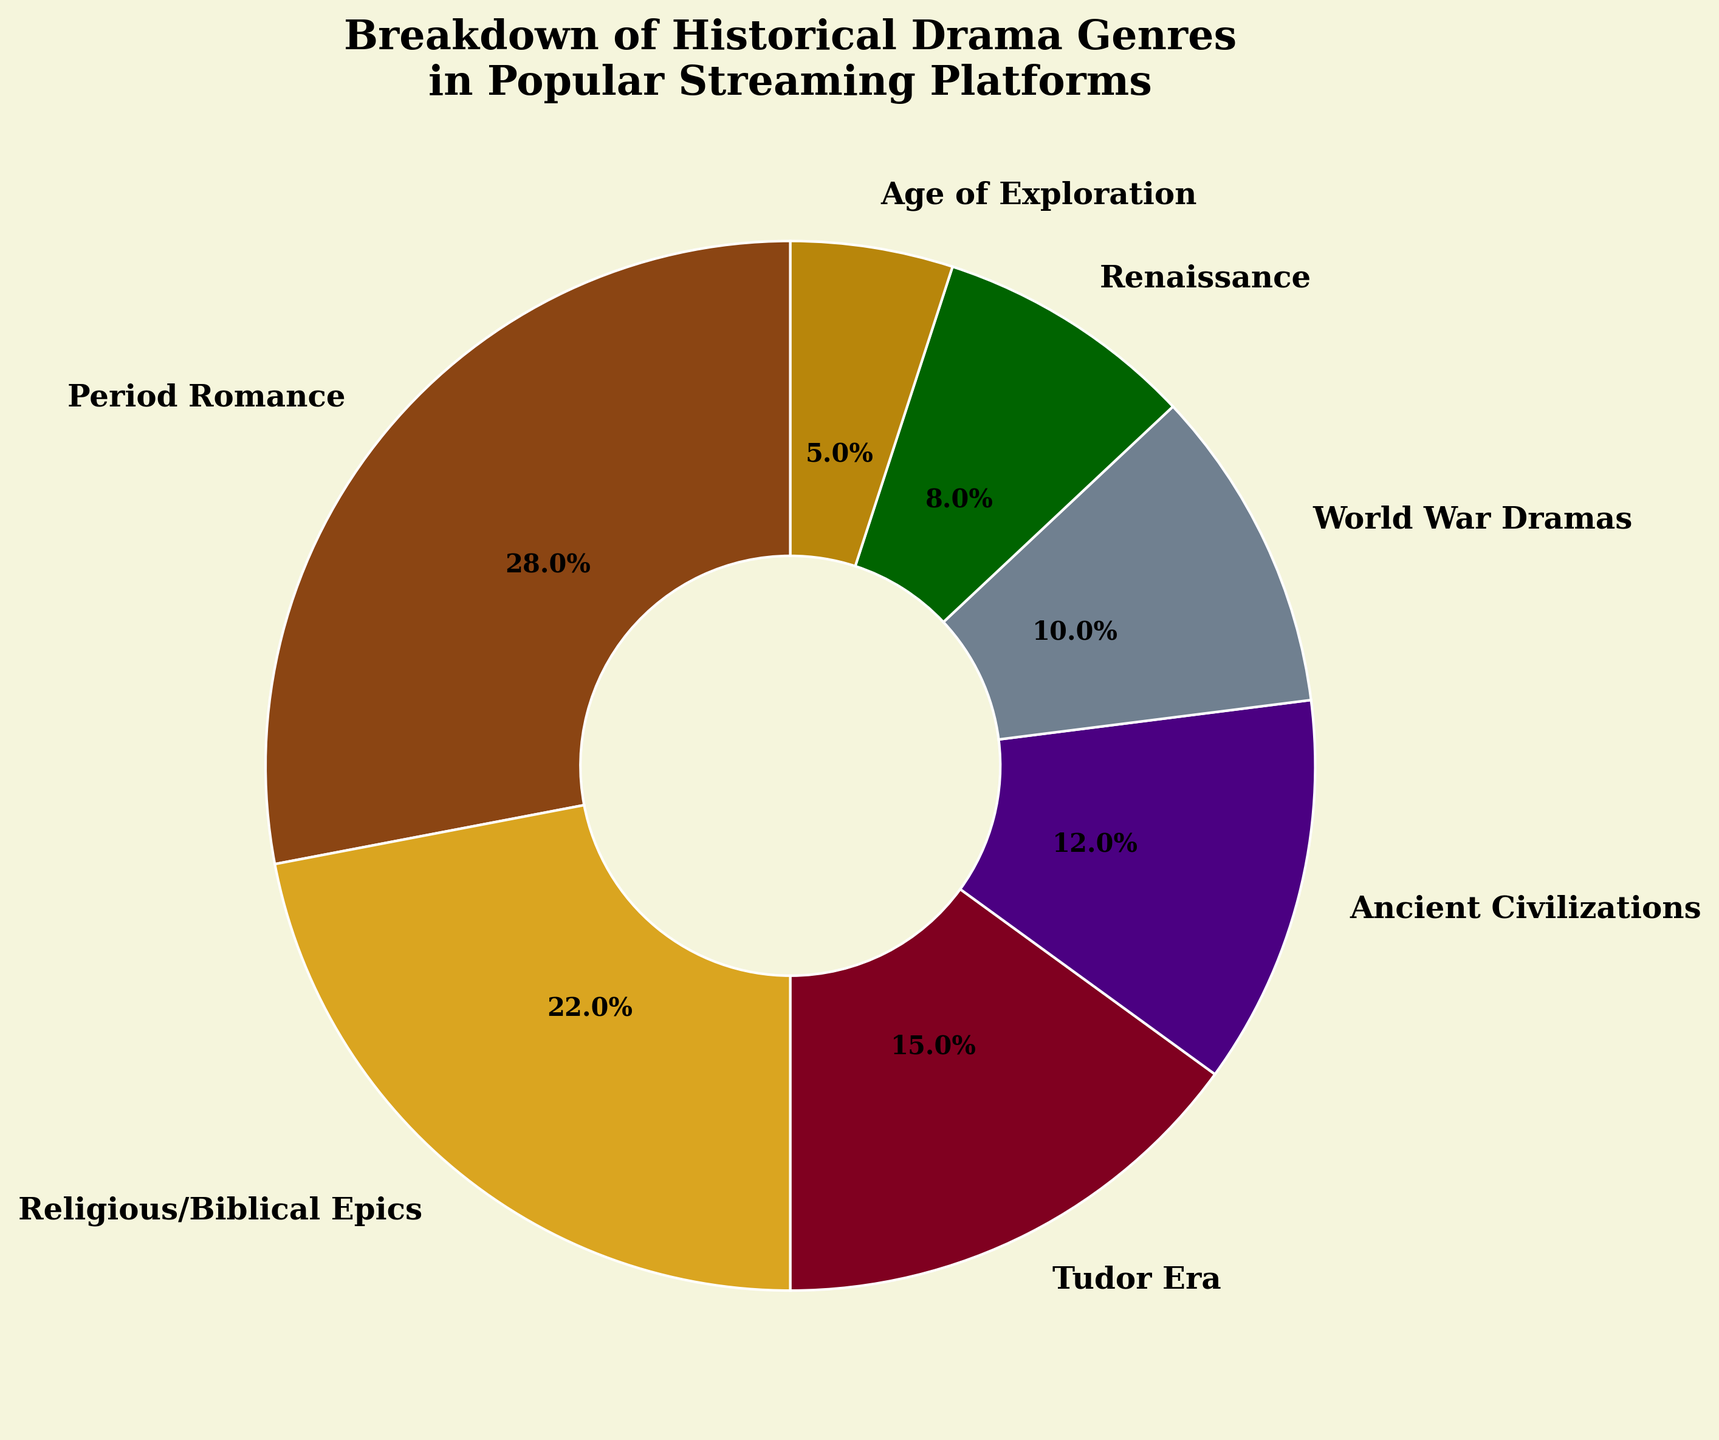What genre has the largest percentage share in the chart? Looking at the data in the pie chart, the genre with the largest percentage is the period romance with 28%.
Answer: Period Romance Which genres account for more than 20% of the total? From the pie chart, both period romance and religious/biblical epics account for more than 20% of the total with 28% and 22% respectively.
Answer: Period Romance, Religious/Biblical Epics How much larger is the percentage share of period romance compared to world war dramas? Period romance has 28% and world war dramas have 10%. The difference is 28% - 10% = 18%.
Answer: 18% What is the combined percentage of the Tudor era and ancient civilizations genres? The Tudor era is 15% and ancient civilizations is 12%. Adding these together, 15% + 12% = 27%.
Answer: 27% Are there any genres with less than 10% share, and if so, what are they? Looking at the pie chart, both the Renaissance and the Age of Exploration have less than 10% share with 8% and 5% respectively.
Answer: Renaissance, Age of Exploration Which genre has the smallest percentage share, and what is it? The pie chart shows that the Age of Exploration has the smallest share with 5%.
Answer: Age of Exploration How does the share of religious/biblical epics compare to the combined share of the Renaissance and Age of Exploration? The religious/biblical epics genre has a share of 22%. The combined share of the Renaissance (8%) and the Age of Exploration (5%) is 13%. Therefore, 22% - 13% = 9% larger.
Answer: 9% Is the percentage share of Tudor era greater than that of ancient civilizations? The Tudor era has a percentage share of 15%, and ancient civilizations have a share of 12%. Thus, Tudor era's share is greater.
Answer: Yes What is the average percentage share of all the genres in the chart? The sum of all percentages is 28 + 22 + 15 + 12 + 10 + 8 + 5 = 100. There are 7 genres, so the average is 100 / 7 ≈ 14.3%.
Answer: 14.3% 